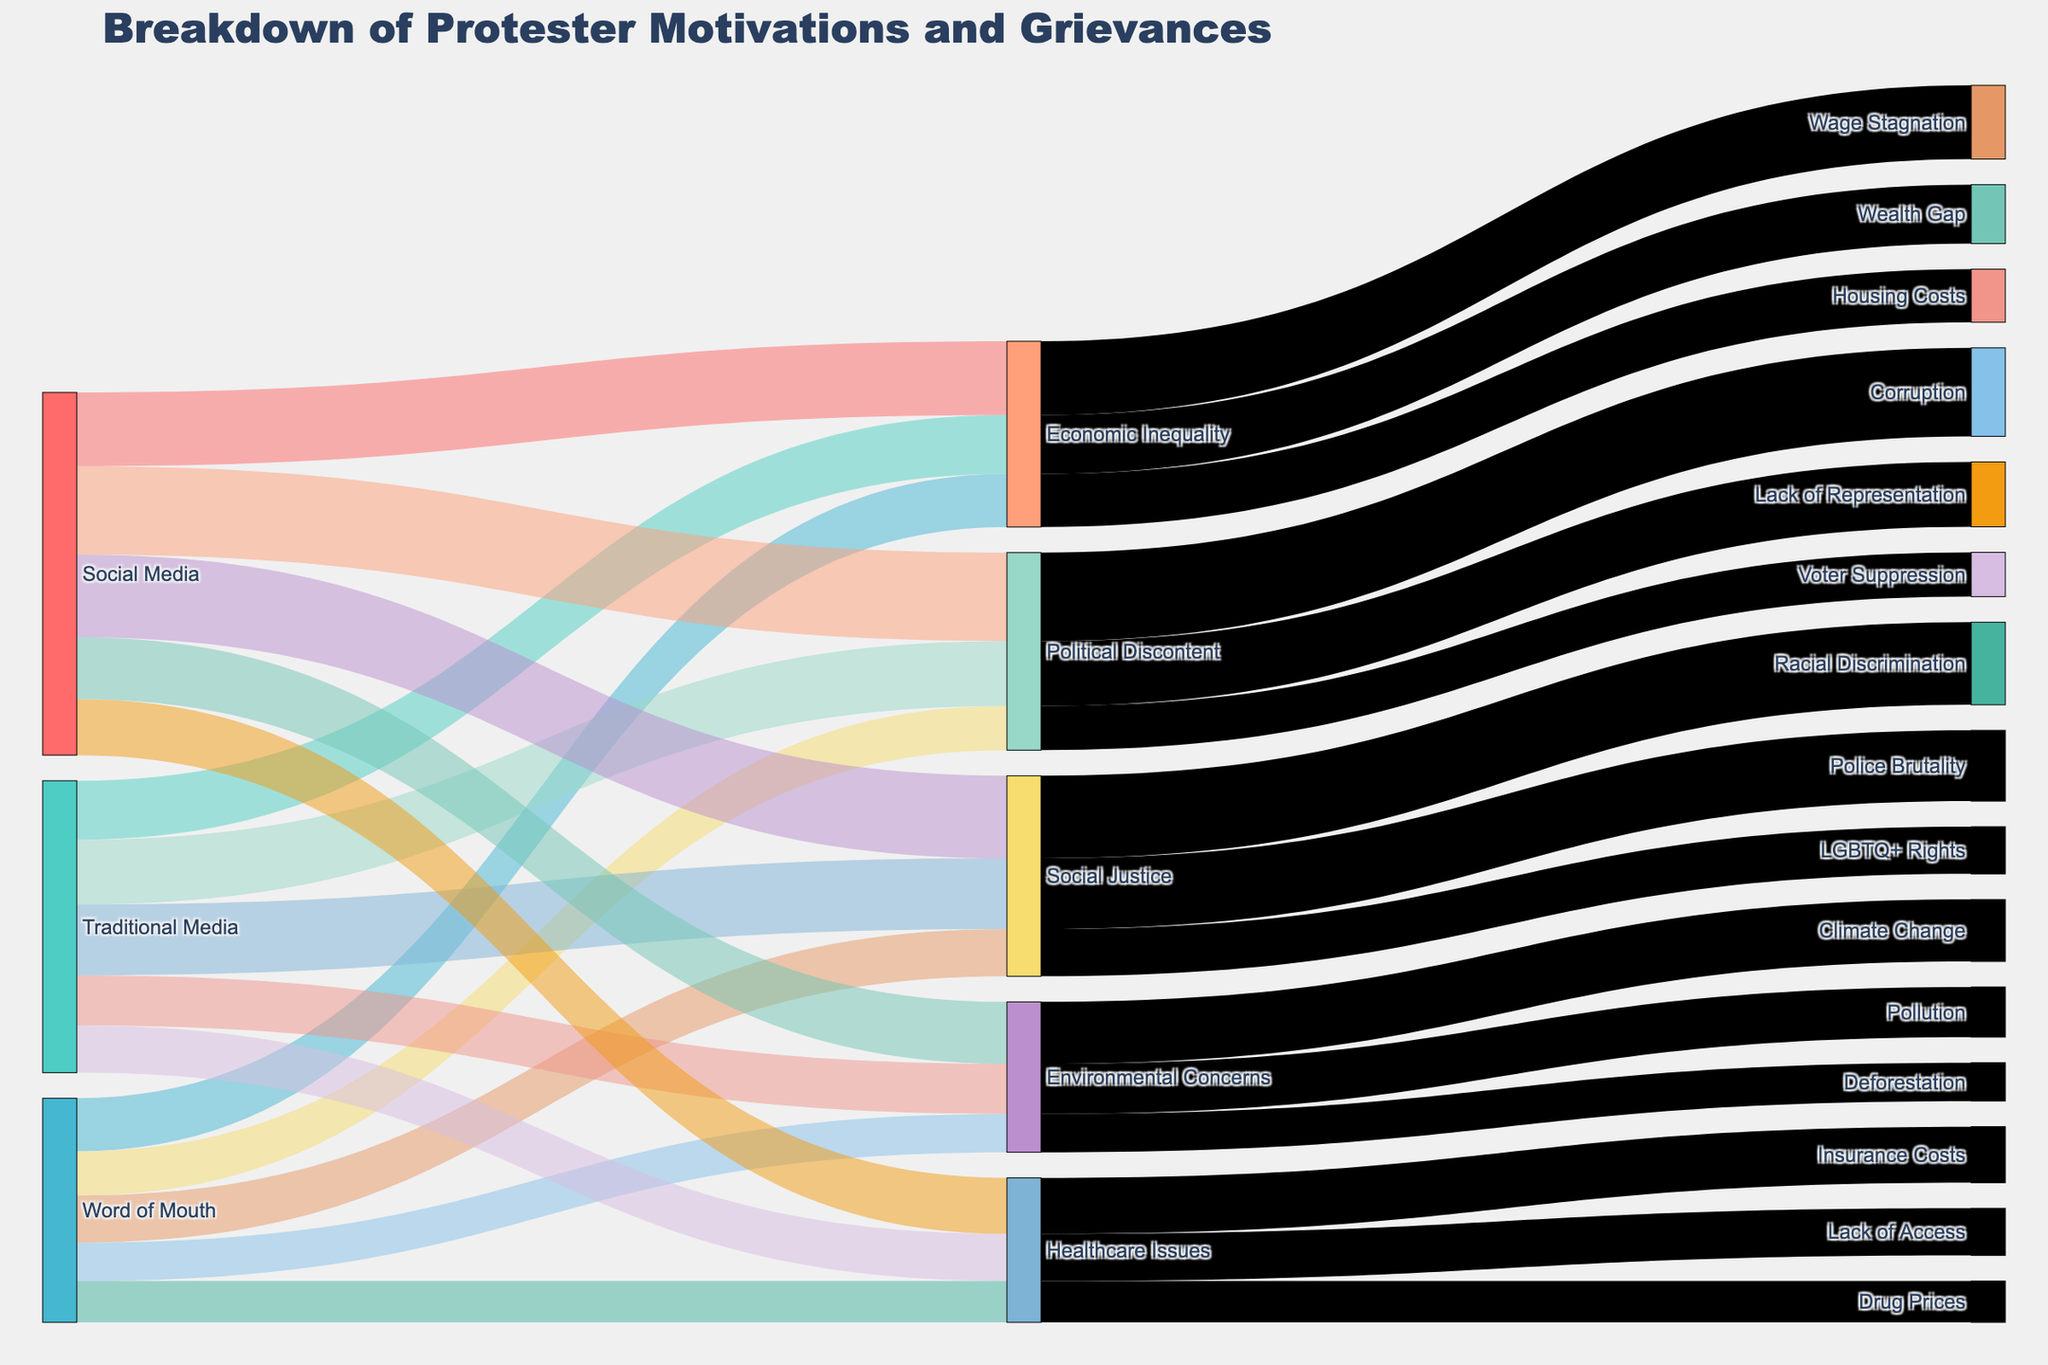what is the primary source of grievances related to 'Political Discontent'? To determine the primary source for 'Political Discontent', look at the first set of links coming from 'Political Discontent' in the diagram: 'Social Media', 'Traditional Media', and 'Word of Mouth'. Comparing their corresponding link values, 'Social Media' has the largest magnitude.
Answer: Social Media which motivation has the highest total number of grievances? To find the total number of grievances for each motivation, sum the values of all links associated with each motivation and compare the sums. 'Political Discontent' has 3000 + 2200 + 1500 = 6700, which is the highest.
Answer: Political Discontent How many grievances are connected to 'Social Media' as the source? Identify all links from 'Social Media' and sum the value counts: 2500 (Economic Inequality) + 3000 (Political Discontent) + 2800 (Social Justice) + 2100 (Environmental Concerns) + 1900 (Healthcare Issues). The total is 12300.
Answer: 12300 which grievance has the least number of issues from 'Word of Mouth' and what is the count? Identify and compare the values of links from 'Word of Mouth'. 'Deforestation' has the least with 1300.
Answer: Deforestation, 1300 Which source has the greatest association with grievances related to 'Economic Inequality'? For grievances related to 'Economic Inequality', look at the links from this motivation to the sources: 'Social Media', 'Traditional Media', and 'Word of Mouth'. 'Social Media' has the highest number at 2500.
Answer: Social Media which source is most frequently associated with 'Social Justice' grievances? Sum the grievance counts related to 'Social Justice' for each source: Social Media (2800), Traditional Media (2400), and Word of Mouth (1600). The highest count is 'Social Media' with 2800.
Answer: Social Media total number of grievances associated with 'Wealth Gap' and 'Housing Costs'? Add the counts for 'Wealth Gap' and 'Housing Costs': 2000 (Wealth Gap) + 1800 (Housing Costs) = 3800
Answer: 3800 Which grievance category has the lowest total count, and what is that count? Sum the grievances across all sources for each category and identify the lowest total: Economic Inequality (6300), Political Discontent (6700), Social Justice (6800), Environmental Concerns (5100), Healthcare Issues (4900). Healthcare Issues has the lowest count of 4900.
Answer: Healthcare Issues, 4900 